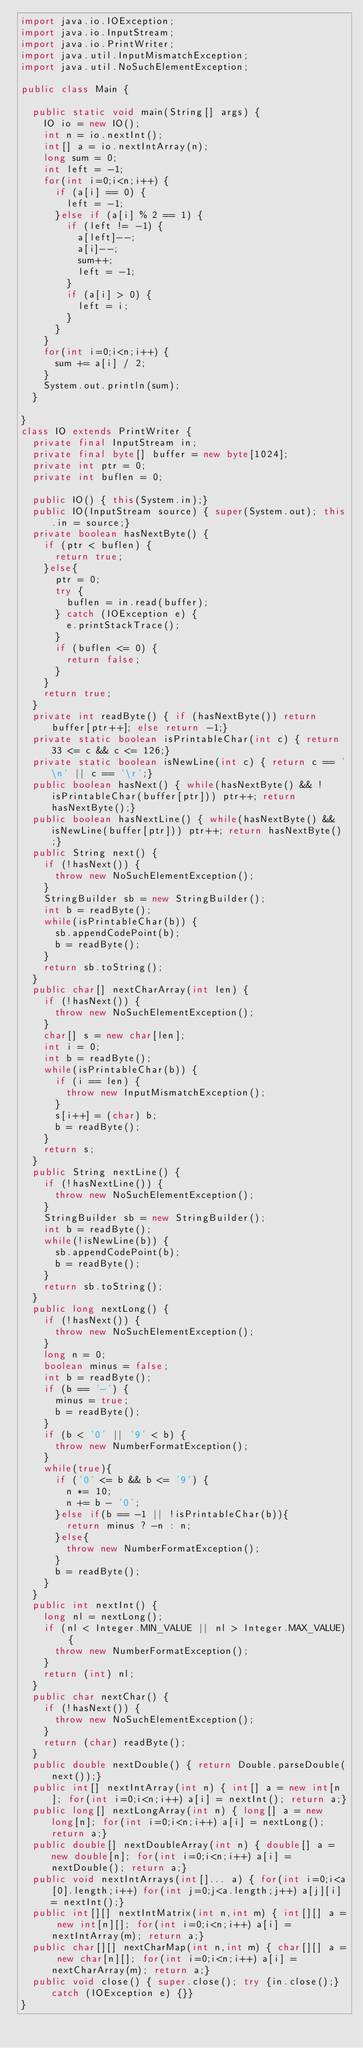Convert code to text. <code><loc_0><loc_0><loc_500><loc_500><_Java_>import java.io.IOException;
import java.io.InputStream;
import java.io.PrintWriter;
import java.util.InputMismatchException;
import java.util.NoSuchElementException;

public class Main {

	public static void main(String[] args) {
		IO io = new IO();
		int n = io.nextInt();
		int[] a = io.nextIntArray(n);
		long sum = 0;
		int left = -1;
		for(int i=0;i<n;i++) {
			if (a[i] == 0) {
				left = -1;
			}else if (a[i] % 2 == 1) {
				if (left != -1) {
					a[left]--;
					a[i]--;
					sum++;
					left = -1;
				}
				if (a[i] > 0) {
					left = i;
				}
			}
		}
		for(int i=0;i<n;i++) {
			sum += a[i] / 2;
		}
		System.out.println(sum);
	}

}
class IO extends PrintWriter {
	private final InputStream in;
	private final byte[] buffer = new byte[1024];
	private int ptr = 0;
	private int buflen = 0;
	
	public IO() { this(System.in);}
	public IO(InputStream source) { super(System.out); this.in = source;}
	private boolean hasNextByte() {
		if (ptr < buflen) {
			return true;
		}else{
			ptr = 0;
			try {
				buflen = in.read(buffer);
			} catch (IOException e) {
				e.printStackTrace();
			}
			if (buflen <= 0) {
				return false;
			}
		}
		return true;
	}
	private int readByte() { if (hasNextByte()) return buffer[ptr++]; else return -1;}
	private static boolean isPrintableChar(int c) { return 33 <= c && c <= 126;}
	private static boolean isNewLine(int c) { return c == '\n' || c == '\r';}
	public boolean hasNext() { while(hasNextByte() && !isPrintableChar(buffer[ptr])) ptr++; return hasNextByte();}
	public boolean hasNextLine() { while(hasNextByte() && isNewLine(buffer[ptr])) ptr++; return hasNextByte();}
	public String next() {
		if (!hasNext()) {
			throw new NoSuchElementException();
		}
		StringBuilder sb = new StringBuilder();
		int b = readByte();
		while(isPrintableChar(b)) {
			sb.appendCodePoint(b);
			b = readByte();
		}
		return sb.toString();
	}
	public char[] nextCharArray(int len) {
		if (!hasNext()) {
			throw new NoSuchElementException();
		}
		char[] s = new char[len];
		int i = 0;
		int b = readByte();
		while(isPrintableChar(b)) {
			if (i == len) {
				throw new InputMismatchException();
			}
			s[i++] = (char) b;
			b = readByte();
		}
		return s;
	}
	public String nextLine() {
		if (!hasNextLine()) {
			throw new NoSuchElementException();
		}
		StringBuilder sb = new StringBuilder();
		int b = readByte();
		while(!isNewLine(b)) {
			sb.appendCodePoint(b);
			b = readByte();
		}
		return sb.toString();
	}
	public long nextLong() {
		if (!hasNext()) {
			throw new NoSuchElementException();
		}
		long n = 0;
		boolean minus = false;
		int b = readByte();
		if (b == '-') {
			minus = true;
			b = readByte();
		}
		if (b < '0' || '9' < b) {
			throw new NumberFormatException();
		}
		while(true){
			if ('0' <= b && b <= '9') {
				n *= 10;
				n += b - '0';
			}else if(b == -1 || !isPrintableChar(b)){
				return minus ? -n : n;
			}else{
				throw new NumberFormatException();
			}
			b = readByte();
		}
	}
	public int nextInt() {
		long nl = nextLong();
		if (nl < Integer.MIN_VALUE || nl > Integer.MAX_VALUE) {
			throw new NumberFormatException();
		}
		return (int) nl;
	}
	public char nextChar() {
		if (!hasNext()) {
			throw new NoSuchElementException();
		}
		return (char) readByte();
	}
	public double nextDouble() { return Double.parseDouble(next());}
	public int[] nextIntArray(int n) { int[] a = new int[n]; for(int i=0;i<n;i++) a[i] = nextInt(); return a;}
	public long[] nextLongArray(int n) { long[] a = new long[n]; for(int i=0;i<n;i++) a[i] = nextLong(); return a;}
	public double[] nextDoubleArray(int n) { double[] a = new double[n]; for(int i=0;i<n;i++) a[i] = nextDouble(); return a;}
	public void nextIntArrays(int[]... a) { for(int i=0;i<a[0].length;i++) for(int j=0;j<a.length;j++) a[j][i] = nextInt();}
	public int[][] nextIntMatrix(int n,int m) { int[][] a = new int[n][]; for(int i=0;i<n;i++) a[i] = nextIntArray(m); return a;}
	public char[][] nextCharMap(int n,int m) { char[][] a = new char[n][]; for(int i=0;i<n;i++) a[i] = nextCharArray(m); return a;}
	public void close() { super.close(); try {in.close();} catch (IOException e) {}}
}

</code> 